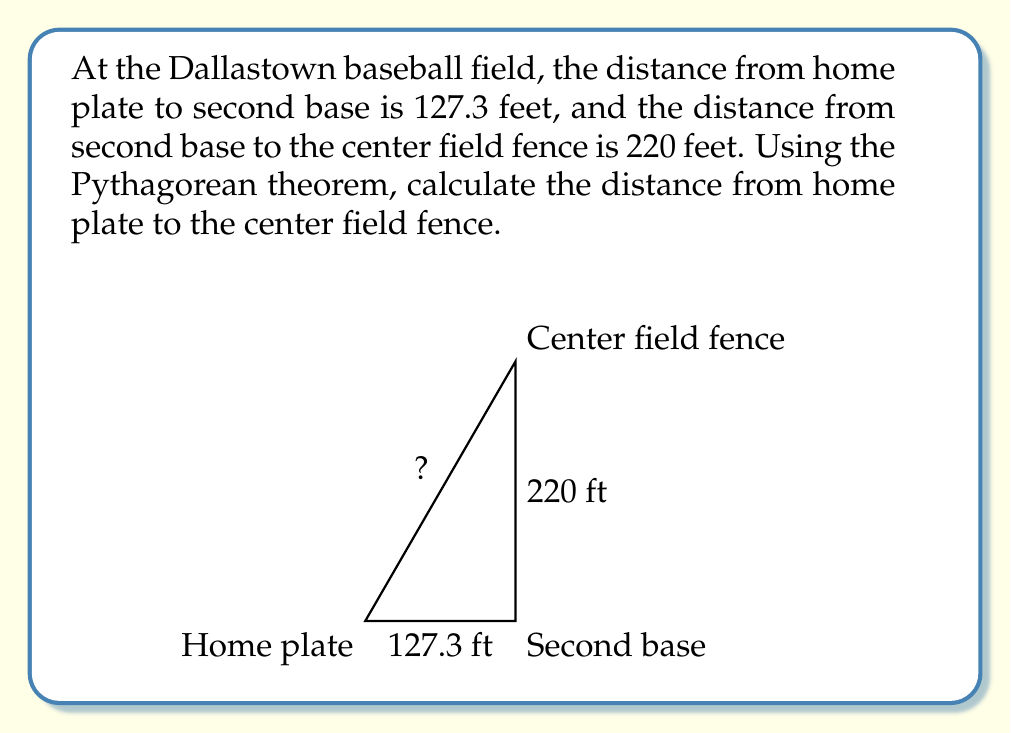Solve this math problem. Let's approach this step-by-step using the Pythagorean theorem:

1) Let's denote the distance from home plate to the center field fence as $x$.

2) We can form a right triangle with:
   - The base as the line from home plate to second base (127.3 feet)
   - The height as the line from second base to the center field fence (220 feet)
   - The hypotenuse as the line we're trying to find (from home plate to center field fence)

3) The Pythagorean theorem states that in a right triangle, $a^2 + b^2 = c^2$, where $c$ is the hypotenuse.

4) Let's plug in our known values:
   $127.3^2 + 220^2 = x^2$

5) Now, let's calculate:
   $16205.29 + 48400 = x^2$
   $64605.29 = x^2$

6) To find $x$, we need to take the square root of both sides:
   $x = \sqrt{64605.29}$

7) Using a calculator:
   $x \approx 254.17$ feet

Therefore, the distance from home plate to the center field fence is approximately 254.17 feet.
Answer: $254.17$ feet 